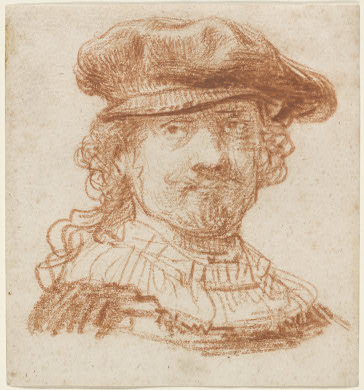Can you create a short story inspired by this portrait? In a quaint town nestled between lush valleys and whispering forests lived a man named Theodore Van Gogh. The time was the Golden Age, an era of exploration and rich cultural flourishing. Theodore, with his hat slightly askew and ruff collar neatly in place, was a renowned artist himself, celebrated for his extraordinary ability to capture the essence of his subjects. One day, as he sat in his sunlit studio, pondering his latest commission, he decided to create a portrait of his own reflection. It was not just an exercise in skill but a journey into his own soul. As his red chalk danced across the beige paper, Theodore captured not just the physical likeness but also the silent tales of his adventures, the warmth of his friendships, and the deep contemplations of his solitary moments. This self-portrait became his legacy, a timeless piece whispering stories of his era to anyone who gazed upon it. What historical significance might this self-portrait hold in the future? Theodore's self-portrait might hold significant historical value, serving as a window into the artistic techniques and cultural norms of the Golden Age. Future generations could study the elaborate details of his attire, gaining insights into the fashion and social structures of the 17th century. The portrait could be a testament to the period's focus on individualism and realism in art, reflecting the broader humanistic currents of the time. For art historians, the piece could offer invaluable knowledge about the use of red chalk as a medium and the stylistic nuances that defined Baroque portraiture. Moreover, Theodore's introspective expression and the craftsmanship would speak to the enduring quest for self-understanding and representation, resonating with themes that continue to be relevant in the art world. If this portrait could enter a magical world, what kind of adventures might it have? In a magical realm filled with other enchanted artworks, Theodore's portrait might come to life, stepping off the paper and wandering through a grand gallery where paintings and sculptures converse and share stories. Theodore, with his newly granted mobility, would explore this artistic universe, engaging in dialogues with mythical creatures and legendary heroes depicted in other works. He might embark on quests to uncover the secrets hidden within ancient manuscripts, or perhaps join forces with other magical portraits to protect the realm from dark forces threatening to erase creativity and imagination. Throughout his adventures, Theodore would use his artistic skills not only as a means of expression but also as a powerful magic, conjuring vivid illusions and creating landscapes that inspire awe and wonder in the inhabitants of this fantastical world. 